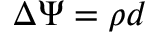<formula> <loc_0><loc_0><loc_500><loc_500>\Delta \Psi = \rho d</formula> 